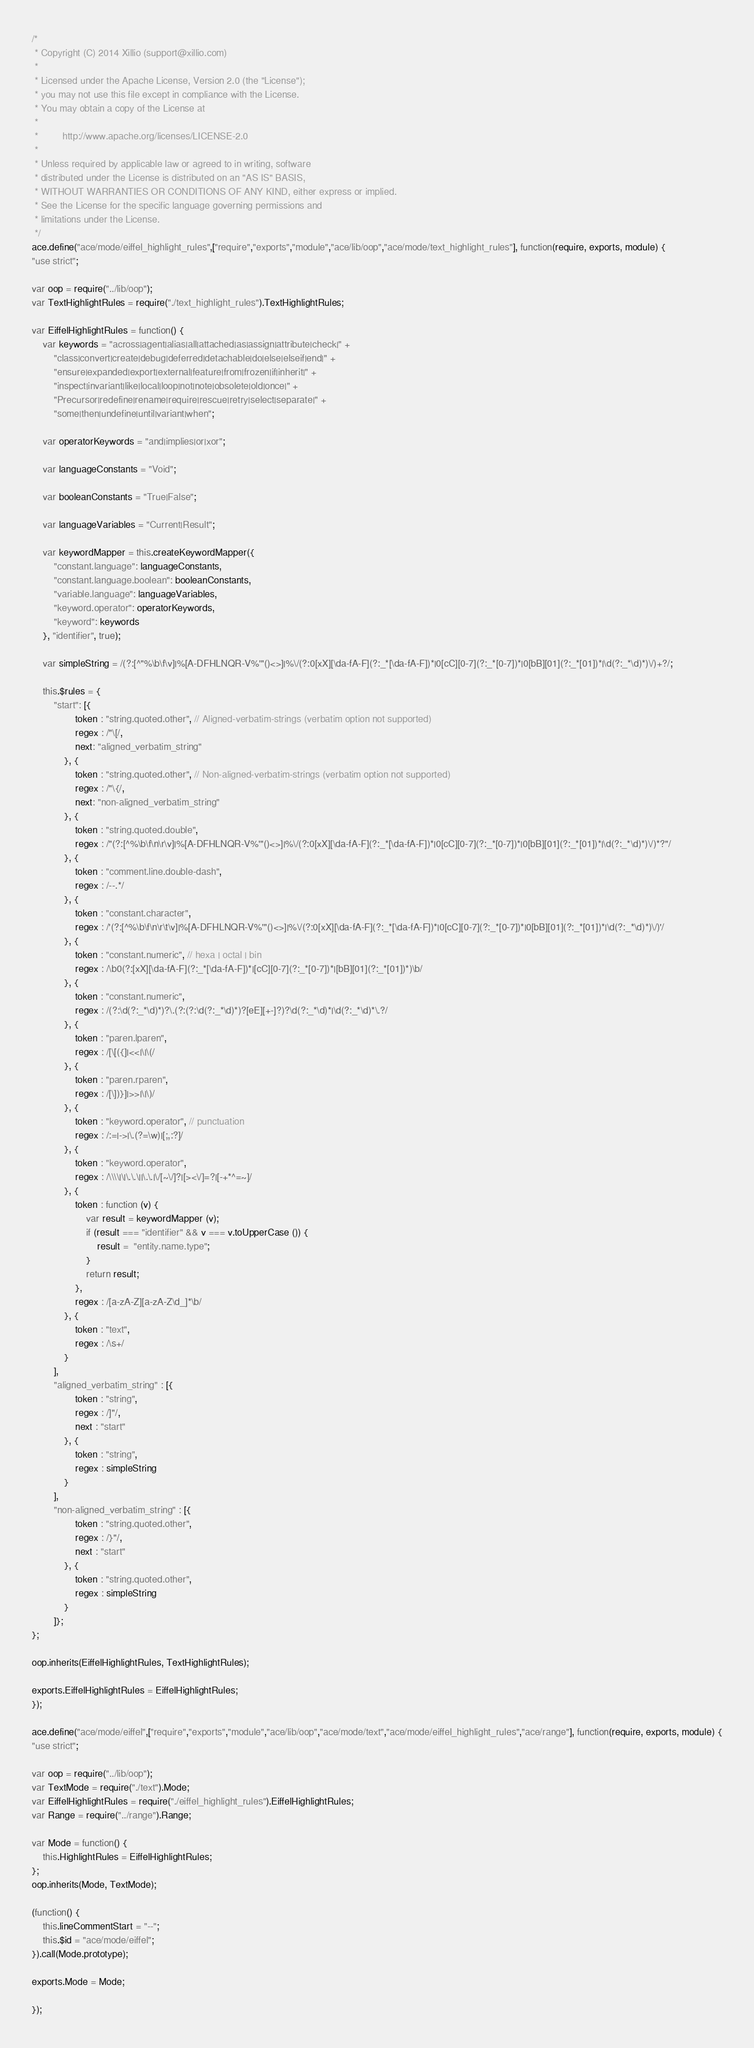<code> <loc_0><loc_0><loc_500><loc_500><_JavaScript_>/*
 * Copyright (C) 2014 Xillio (support@xillio.com)
 *
 * Licensed under the Apache License, Version 2.0 (the "License");
 * you may not use this file except in compliance with the License.
 * You may obtain a copy of the License at
 *
 *         http://www.apache.org/licenses/LICENSE-2.0
 *
 * Unless required by applicable law or agreed to in writing, software
 * distributed under the License is distributed on an "AS IS" BASIS,
 * WITHOUT WARRANTIES OR CONDITIONS OF ANY KIND, either express or implied.
 * See the License for the specific language governing permissions and
 * limitations under the License.
 */
ace.define("ace/mode/eiffel_highlight_rules",["require","exports","module","ace/lib/oop","ace/mode/text_highlight_rules"], function(require, exports, module) {
"use strict";

var oop = require("../lib/oop");
var TextHighlightRules = require("./text_highlight_rules").TextHighlightRules;

var EiffelHighlightRules = function() {
    var keywords = "across|agent|alias|all|attached|as|assign|attribute|check|" +
        "class|convert|create|debug|deferred|detachable|do|else|elseif|end|" +
        "ensure|expanded|export|external|feature|from|frozen|if|inherit|" +
        "inspect|invariant|like|local|loop|not|note|obsolete|old|once|" +
        "Precursor|redefine|rename|require|rescue|retry|select|separate|" +
        "some|then|undefine|until|variant|when";

    var operatorKeywords = "and|implies|or|xor";

    var languageConstants = "Void";

    var booleanConstants = "True|False";

    var languageVariables = "Current|Result";

    var keywordMapper = this.createKeywordMapper({
        "constant.language": languageConstants,
        "constant.language.boolean": booleanConstants,
        "variable.language": languageVariables,
        "keyword.operator": operatorKeywords,
        "keyword": keywords
    }, "identifier", true);

    var simpleString = /(?:[^"%\b\f\v]|%[A-DFHLNQR-V%'"()<>]|%\/(?:0[xX][\da-fA-F](?:_*[\da-fA-F])*|0[cC][0-7](?:_*[0-7])*|0[bB][01](?:_*[01])*|\d(?:_*\d)*)\/)+?/;

    this.$rules = {
        "start": [{
                token : "string.quoted.other", // Aligned-verbatim-strings (verbatim option not supported)
                regex : /"\[/,
                next: "aligned_verbatim_string"
            }, {
                token : "string.quoted.other", // Non-aligned-verbatim-strings (verbatim option not supported)
                regex : /"\{/,
                next: "non-aligned_verbatim_string"
            }, {
                token : "string.quoted.double",
                regex : /"(?:[^%\b\f\n\r\v]|%[A-DFHLNQR-V%'"()<>]|%\/(?:0[xX][\da-fA-F](?:_*[\da-fA-F])*|0[cC][0-7](?:_*[0-7])*|0[bB][01](?:_*[01])*|\d(?:_*\d)*)\/)*?"/
            }, {
                token : "comment.line.double-dash",
                regex : /--.*/
            }, {
                token : "constant.character",
                regex : /'(?:[^%\b\f\n\r\t\v]|%[A-DFHLNQR-V%'"()<>]|%\/(?:0[xX][\da-fA-F](?:_*[\da-fA-F])*|0[cC][0-7](?:_*[0-7])*|0[bB][01](?:_*[01])*|\d(?:_*\d)*)\/)'/
            }, {
                token : "constant.numeric", // hexa | octal | bin
                regex : /\b0(?:[xX][\da-fA-F](?:_*[\da-fA-F])*|[cC][0-7](?:_*[0-7])*|[bB][01](?:_*[01])*)\b/
            }, {
                token : "constant.numeric",
                regex : /(?:\d(?:_*\d)*)?\.(?:(?:\d(?:_*\d)*)?[eE][+-]?)?\d(?:_*\d)*|\d(?:_*\d)*\.?/
            }, {
                token : "paren.lparen",
                regex : /[\[({]|<<|\|\(/
            }, {
                token : "paren.rparen",
                regex : /[\])}]|>>|\|\)/
            }, {
                token : "keyword.operator", // punctuation
                regex : /:=|->|\.(?=\w)|[;,:?]/
            }, {
                token : "keyword.operator",
                regex : /\\\\|\|\.\.\||\.\.|\/[~\/]?|[><\/]=?|[-+*^=~]/
            }, {
                token : function (v) {
                    var result = keywordMapper (v);
                    if (result === "identifier" && v === v.toUpperCase ()) {
                        result =  "entity.name.type";
                    }
                    return result;
                },
                regex : /[a-zA-Z][a-zA-Z\d_]*\b/
            }, {
                token : "text",
                regex : /\s+/
            }
        ],
        "aligned_verbatim_string" : [{
                token : "string",
                regex : /]"/,
                next : "start"
            }, {
                token : "string",
                regex : simpleString
            }
        ],
        "non-aligned_verbatim_string" : [{
                token : "string.quoted.other",
                regex : /}"/,
                next : "start"
            }, {
                token : "string.quoted.other",
                regex : simpleString
            }
        ]};
};

oop.inherits(EiffelHighlightRules, TextHighlightRules);

exports.EiffelHighlightRules = EiffelHighlightRules;
});

ace.define("ace/mode/eiffel",["require","exports","module","ace/lib/oop","ace/mode/text","ace/mode/eiffel_highlight_rules","ace/range"], function(require, exports, module) {
"use strict";

var oop = require("../lib/oop");
var TextMode = require("./text").Mode;
var EiffelHighlightRules = require("./eiffel_highlight_rules").EiffelHighlightRules;
var Range = require("../range").Range;

var Mode = function() {
    this.HighlightRules = EiffelHighlightRules;
};
oop.inherits(Mode, TextMode);

(function() {
    this.lineCommentStart = "--";
    this.$id = "ace/mode/eiffel";
}).call(Mode.prototype);

exports.Mode = Mode;

});
</code> 